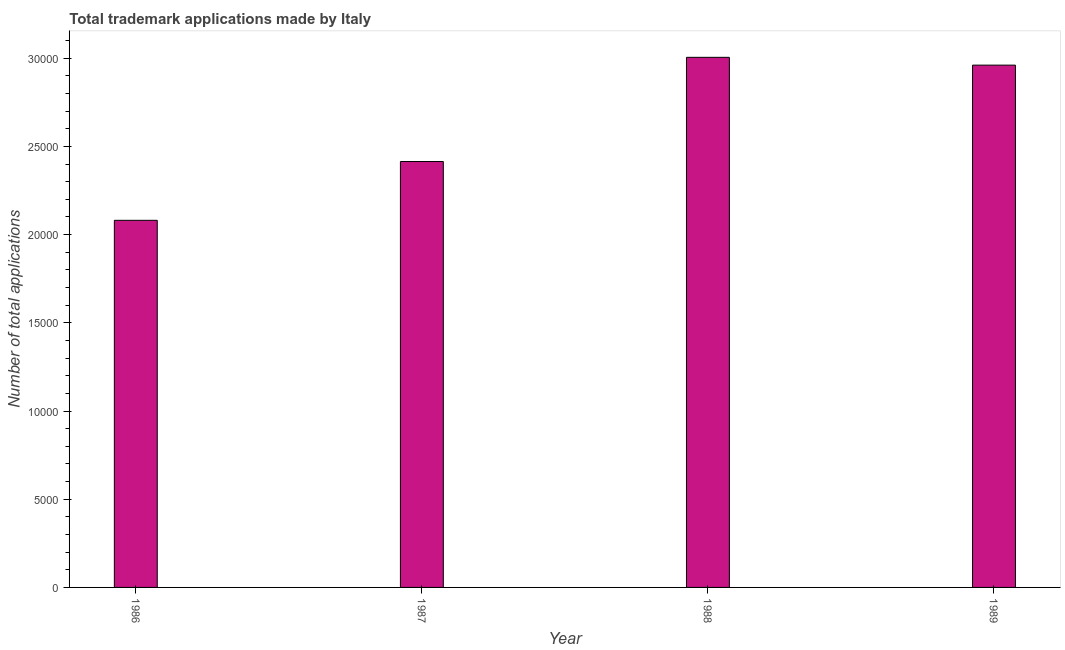Does the graph contain any zero values?
Your answer should be compact. No. Does the graph contain grids?
Your answer should be compact. No. What is the title of the graph?
Provide a succinct answer. Total trademark applications made by Italy. What is the label or title of the X-axis?
Offer a very short reply. Year. What is the label or title of the Y-axis?
Ensure brevity in your answer.  Number of total applications. What is the number of trademark applications in 1988?
Offer a terse response. 3.01e+04. Across all years, what is the maximum number of trademark applications?
Your answer should be compact. 3.01e+04. Across all years, what is the minimum number of trademark applications?
Provide a short and direct response. 2.08e+04. In which year was the number of trademark applications maximum?
Keep it short and to the point. 1988. What is the sum of the number of trademark applications?
Give a very brief answer. 1.05e+05. What is the difference between the number of trademark applications in 1987 and 1988?
Give a very brief answer. -5907. What is the average number of trademark applications per year?
Offer a terse response. 2.62e+04. What is the median number of trademark applications?
Keep it short and to the point. 2.69e+04. What is the ratio of the number of trademark applications in 1986 to that in 1987?
Offer a terse response. 0.86. Is the number of trademark applications in 1986 less than that in 1989?
Offer a terse response. Yes. What is the difference between the highest and the second highest number of trademark applications?
Offer a very short reply. 442. Is the sum of the number of trademark applications in 1987 and 1988 greater than the maximum number of trademark applications across all years?
Ensure brevity in your answer.  Yes. What is the difference between the highest and the lowest number of trademark applications?
Ensure brevity in your answer.  9240. How many bars are there?
Keep it short and to the point. 4. How many years are there in the graph?
Your answer should be compact. 4. What is the Number of total applications of 1986?
Provide a succinct answer. 2.08e+04. What is the Number of total applications in 1987?
Ensure brevity in your answer.  2.41e+04. What is the Number of total applications of 1988?
Ensure brevity in your answer.  3.01e+04. What is the Number of total applications in 1989?
Provide a succinct answer. 2.96e+04. What is the difference between the Number of total applications in 1986 and 1987?
Keep it short and to the point. -3333. What is the difference between the Number of total applications in 1986 and 1988?
Your answer should be very brief. -9240. What is the difference between the Number of total applications in 1986 and 1989?
Provide a succinct answer. -8798. What is the difference between the Number of total applications in 1987 and 1988?
Your response must be concise. -5907. What is the difference between the Number of total applications in 1987 and 1989?
Keep it short and to the point. -5465. What is the difference between the Number of total applications in 1988 and 1989?
Your answer should be compact. 442. What is the ratio of the Number of total applications in 1986 to that in 1987?
Ensure brevity in your answer.  0.86. What is the ratio of the Number of total applications in 1986 to that in 1988?
Offer a terse response. 0.69. What is the ratio of the Number of total applications in 1986 to that in 1989?
Your response must be concise. 0.7. What is the ratio of the Number of total applications in 1987 to that in 1988?
Your answer should be compact. 0.8. What is the ratio of the Number of total applications in 1987 to that in 1989?
Give a very brief answer. 0.81. What is the ratio of the Number of total applications in 1988 to that in 1989?
Your response must be concise. 1.01. 